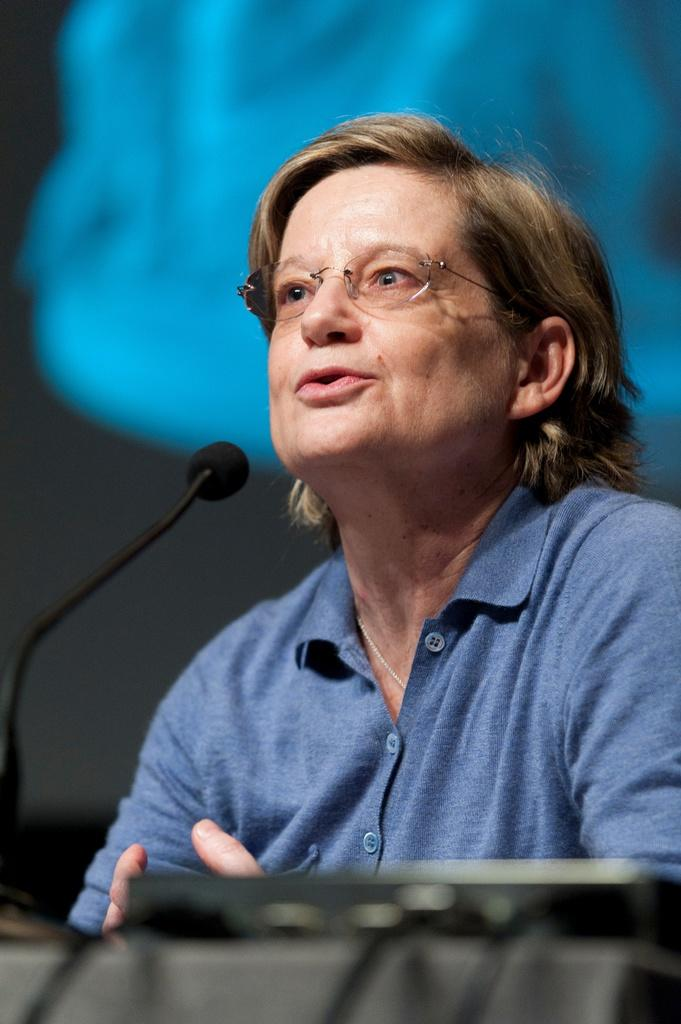Who is the main subject in the image? There is a woman in the image. What object is present in the image? There is a mic in the image. How is the mic positioned in relation to the woman? The mic is positioned before the woman. What type of brass instrument is the woman playing in the image? There is no brass instrument present in the image; the woman is not playing any instrument. How does the bat interact with the mic in the image? There is no bat present in the image; the mic is positioned before the woman, not a bat. 